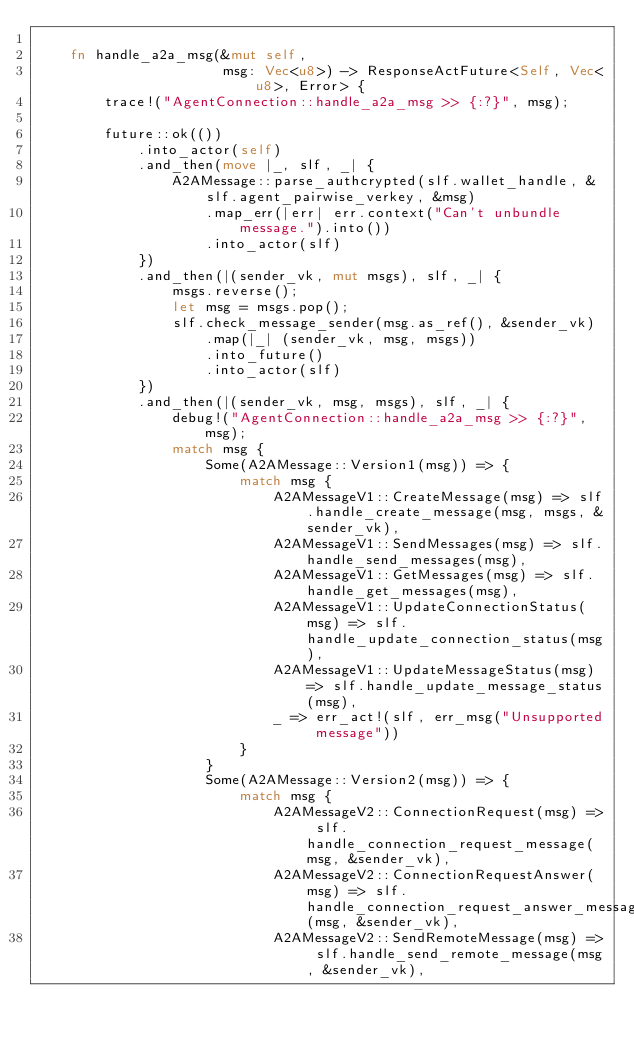Convert code to text. <code><loc_0><loc_0><loc_500><loc_500><_Rust_>
    fn handle_a2a_msg(&mut self,
                      msg: Vec<u8>) -> ResponseActFuture<Self, Vec<u8>, Error> {
        trace!("AgentConnection::handle_a2a_msg >> {:?}", msg);

        future::ok(())
            .into_actor(self)
            .and_then(move |_, slf, _| {
                A2AMessage::parse_authcrypted(slf.wallet_handle, &slf.agent_pairwise_verkey, &msg)
                    .map_err(|err| err.context("Can't unbundle message.").into())
                    .into_actor(slf)
            })
            .and_then(|(sender_vk, mut msgs), slf, _| {
                msgs.reverse();
                let msg = msgs.pop();
                slf.check_message_sender(msg.as_ref(), &sender_vk)
                    .map(|_| (sender_vk, msg, msgs))
                    .into_future()
                    .into_actor(slf)
            })
            .and_then(|(sender_vk, msg, msgs), slf, _| {
                debug!("AgentConnection::handle_a2a_msg >> {:?}", msg);
                match msg {
                    Some(A2AMessage::Version1(msg)) => {
                        match msg {
                            A2AMessageV1::CreateMessage(msg) => slf.handle_create_message(msg, msgs, &sender_vk),
                            A2AMessageV1::SendMessages(msg) => slf.handle_send_messages(msg),
                            A2AMessageV1::GetMessages(msg) => slf.handle_get_messages(msg),
                            A2AMessageV1::UpdateConnectionStatus(msg) => slf.handle_update_connection_status(msg),
                            A2AMessageV1::UpdateMessageStatus(msg) => slf.handle_update_message_status(msg),
                            _ => err_act!(slf, err_msg("Unsupported message"))
                        }
                    }
                    Some(A2AMessage::Version2(msg)) => {
                        match msg {
                            A2AMessageV2::ConnectionRequest(msg) => slf.handle_connection_request_message(msg, &sender_vk),
                            A2AMessageV2::ConnectionRequestAnswer(msg) => slf.handle_connection_request_answer_message(msg, &sender_vk),
                            A2AMessageV2::SendRemoteMessage(msg) => slf.handle_send_remote_message(msg, &sender_vk),</code> 